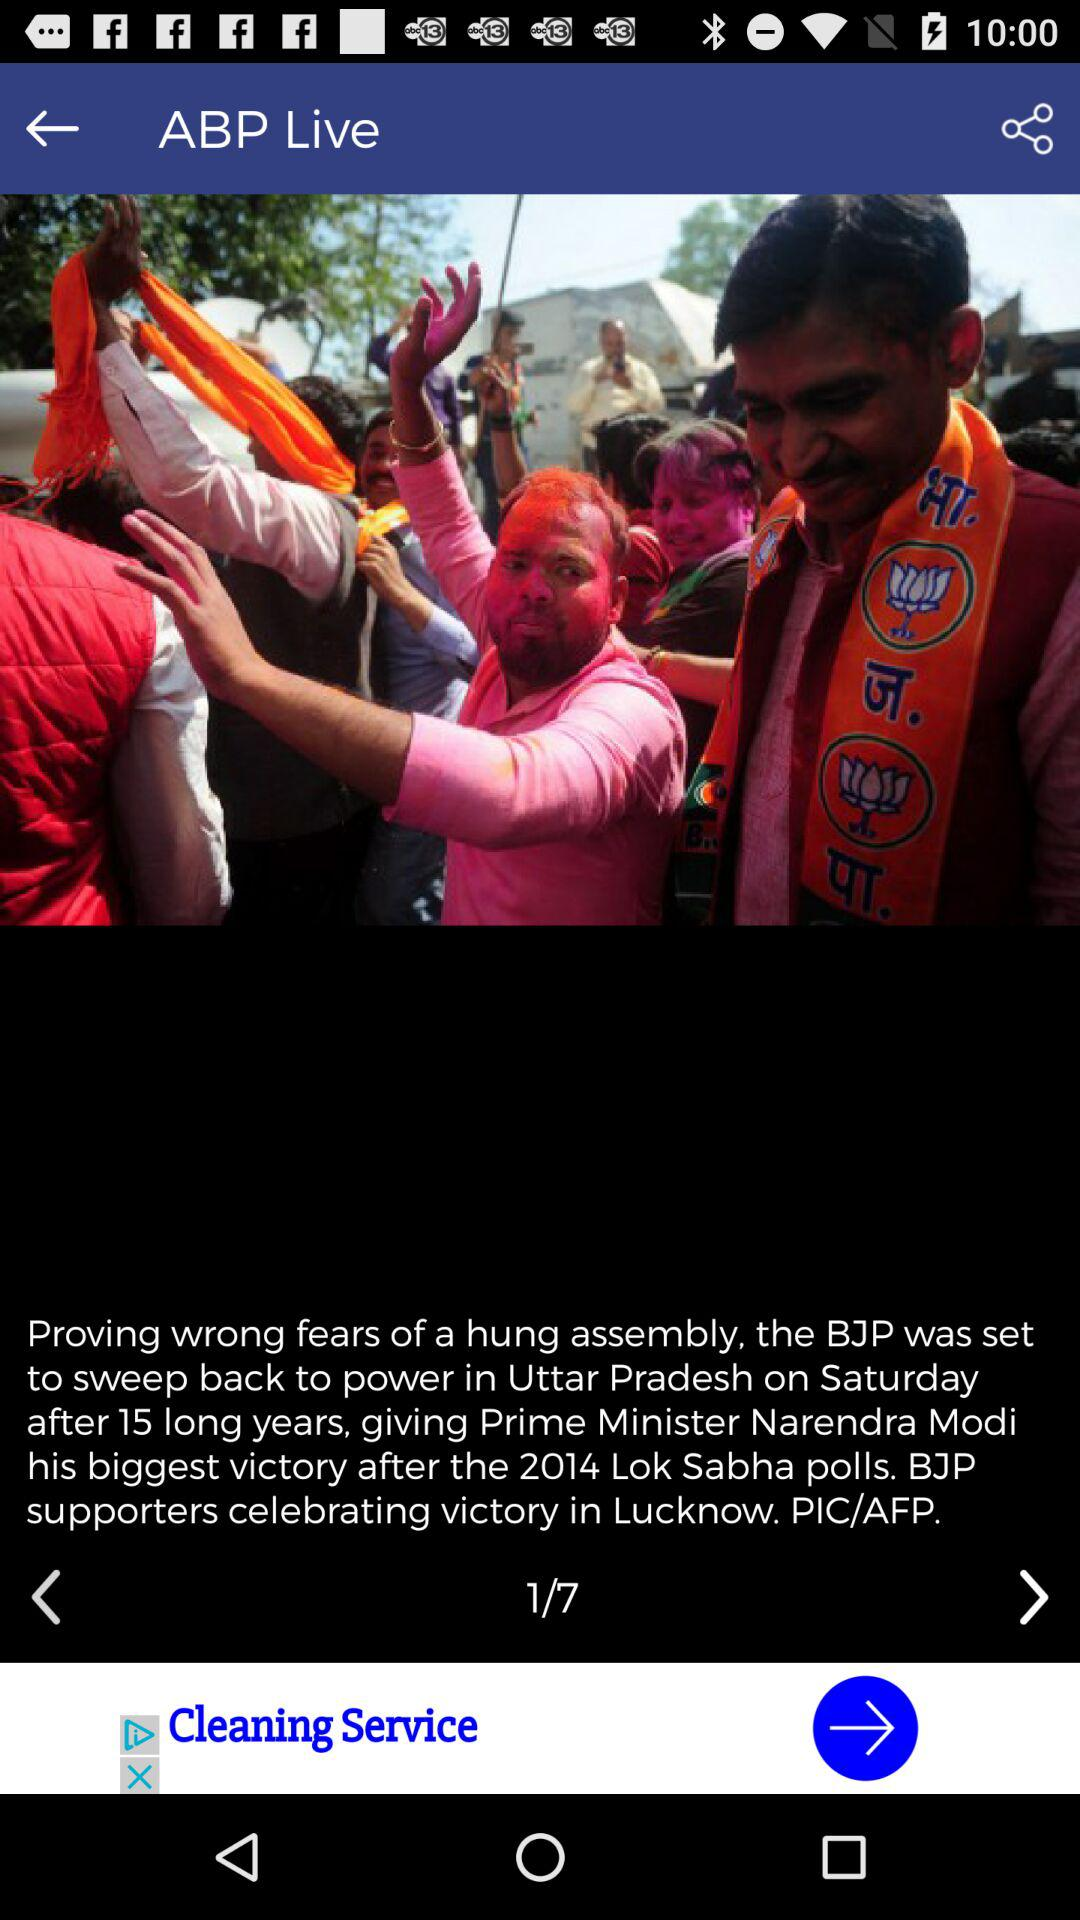In which city are BJP supporters celebrating the victory? BJP supporters are celebrating the victory in Lucknow. 